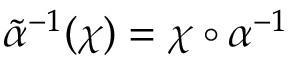Convert formula to latex. <formula><loc_0><loc_0><loc_500><loc_500>\tilde { \alpha ^ { - 1 } ( \chi ) = \chi \circ \alpha ^ { - 1 }</formula> 